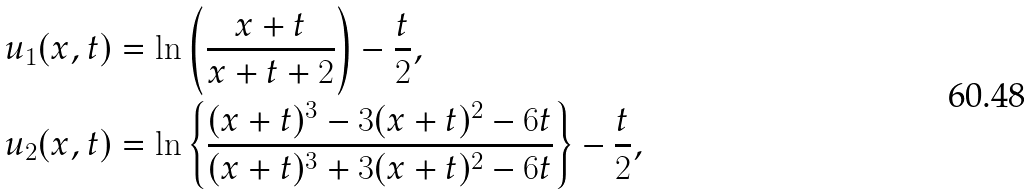Convert formula to latex. <formula><loc_0><loc_0><loc_500><loc_500>u _ { 1 } ( x , t ) & = \ln \left ( \frac { x + t } { x + t + 2 } \right ) - \frac { t } { 2 } , \\ u _ { 2 } ( x , t ) & = \ln \left \{ \frac { ( x + t ) ^ { 3 } - 3 ( x + t ) ^ { 2 } - 6 t } { ( x + t ) ^ { 3 } + 3 ( x + t ) ^ { 2 } - 6 t } \right \} - \frac { t } { 2 } ,</formula> 